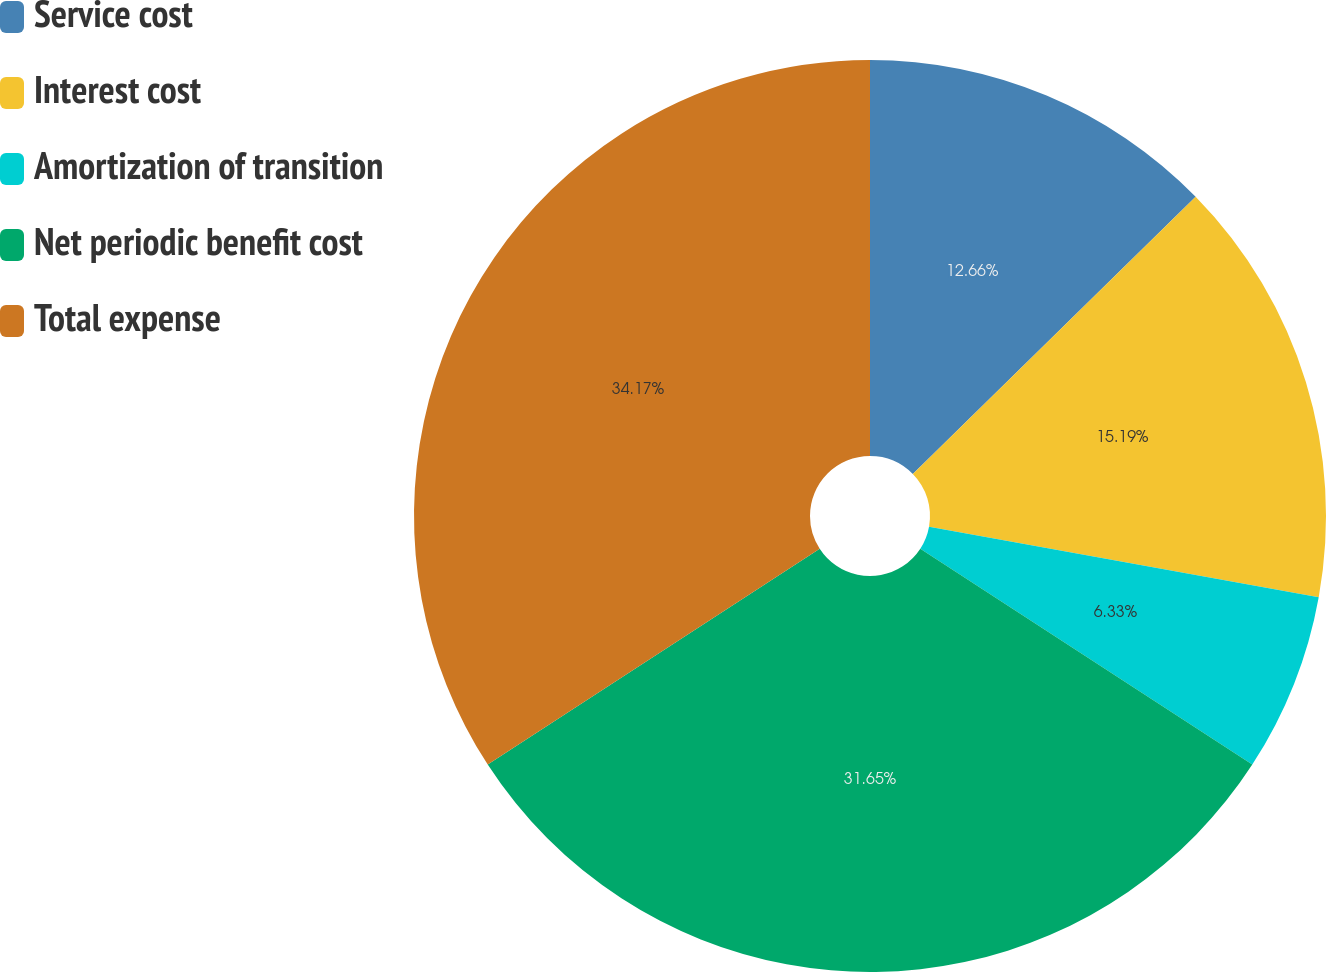<chart> <loc_0><loc_0><loc_500><loc_500><pie_chart><fcel>Service cost<fcel>Interest cost<fcel>Amortization of transition<fcel>Net periodic benefit cost<fcel>Total expense<nl><fcel>12.66%<fcel>15.19%<fcel>6.33%<fcel>31.65%<fcel>34.18%<nl></chart> 